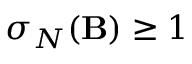Convert formula to latex. <formula><loc_0><loc_0><loc_500><loc_500>\sigma _ { { N } } ( { B } ) \geq 1</formula> 